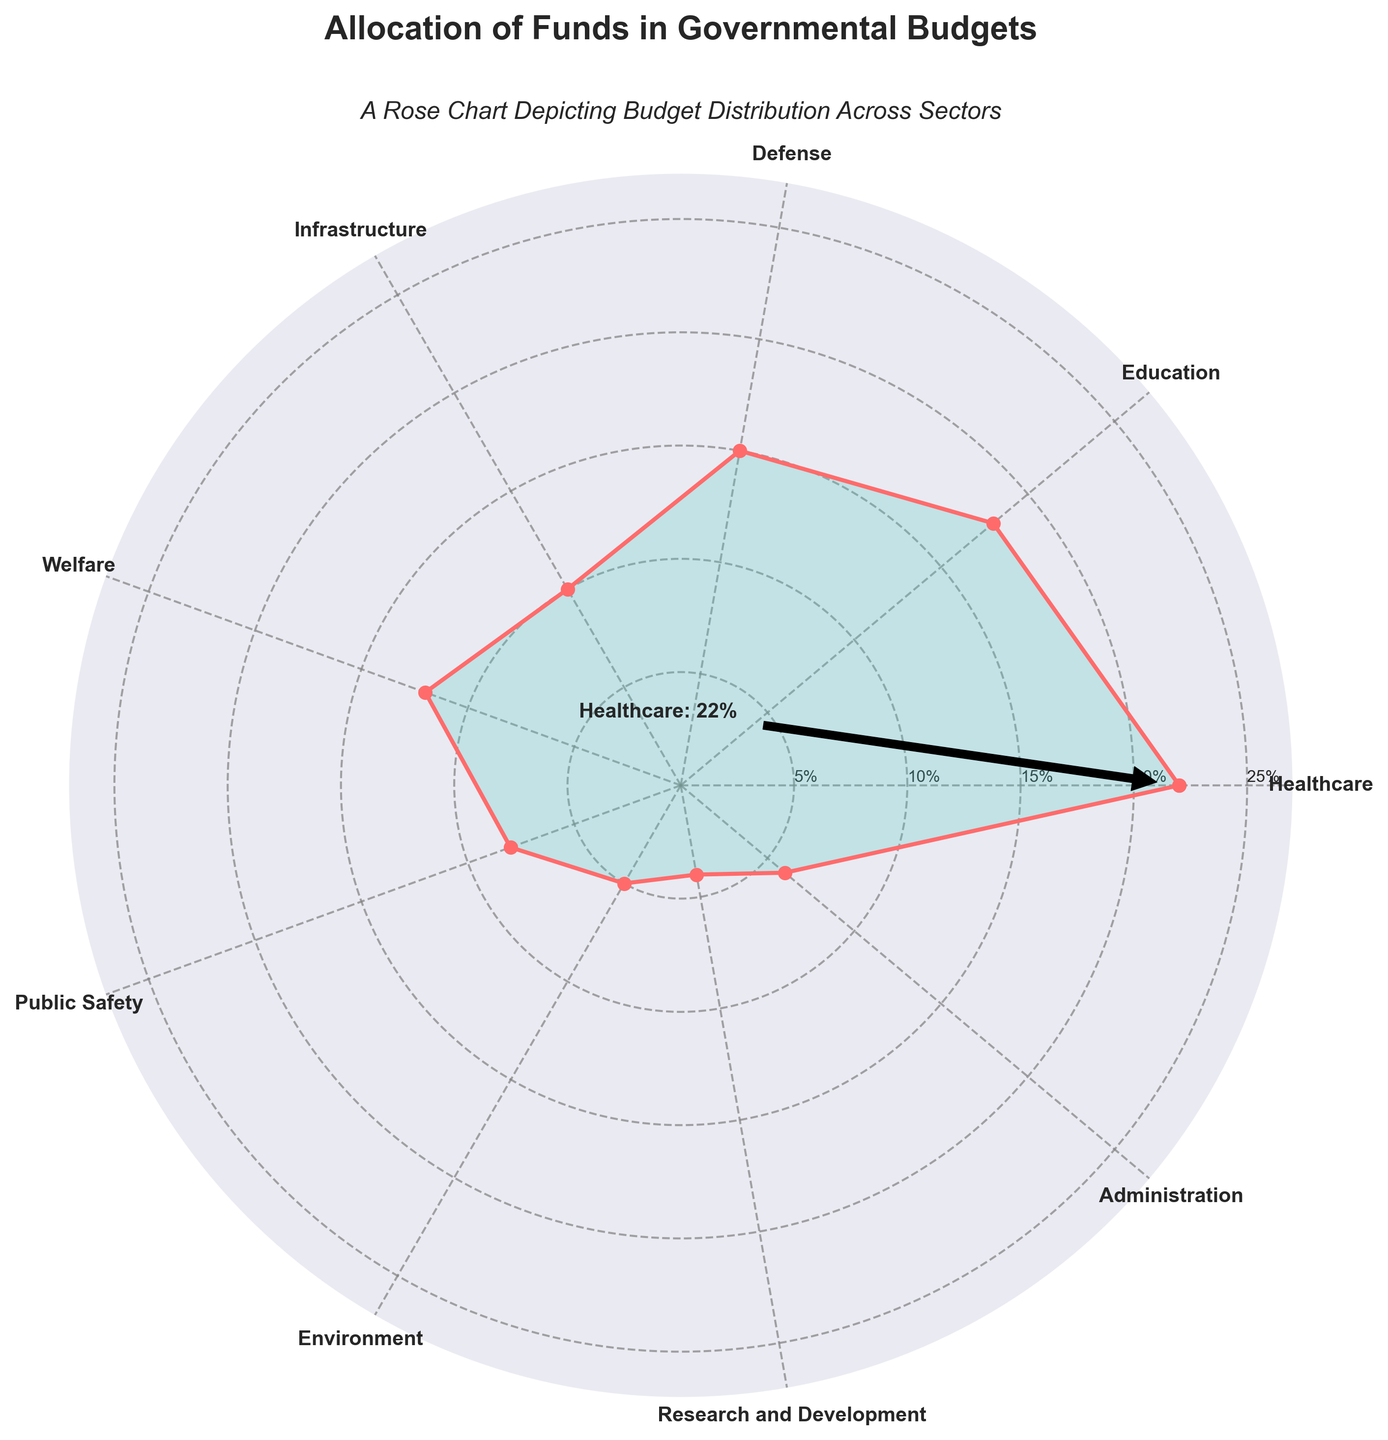What sector receives the highest allocation of funds? The highest point on the rose chart is marked with an annotation. The sector corresponding to this point is Healthcare with 22%.
Answer: Healthcare What is the title of the chart? The title is prominent at the top center of the chart, it reads "Allocation of Funds in Governmental Budgets".
Answer: Allocation of Funds in Governmental Budgets Which sector receives the least amount of funding? Look for the shortest sector on the rose chart. The sector corresponding to this is Research and Development with 4%.
Answer: Research and Development How many sectors have funding allocations greater than 10%? By examining the radial values, count the sectors with percentages above 10%. These are Healthcare (22%), Education (18%), Defense (15%), and Welfare (12%) which give us 4 sectors.
Answer: 4 Compare the funding allocated for Defense and Environment. Which sector receives more? On the rose chart, Defense is allocated 15% whereas Environment is allocated 5%. Defense has a higher allocation.
Answer: Defense What is the sum of percentages allocated to Healthcare, Education, and Defense? The percentages are 22%, 18%, and 15% respectively. Adding these gives 22 + 18 + 15 = 55%.
Answer: 55% By how much does the percentage allocation for Infrastructure exceed that for Administration? Infrastructure is allocated 10% while Administration is allocated 6%. The difference is 10 - 6 = 4%.
Answer: 4% What is the average percentage allocated across all the sectors? Sum of all percentages is 22 + 18 + 15 + 10 + 12 + 8 + 5 + 4 + 6 = 100. There are 9 sectors, so the average is 100 / 9 ≈ 11.11%.
Answer: 11.11% What color is used to fill the sectors in the rose chart? The sectors are filled with a shade of green.
Answer: Green Which sectors fall between the 5% and 10% mark? Sectors within this range are Infrastructure (10%), Public Safety (8%), Environment (5%), and Administration (6%).
Answer: Infrastructure, Public Safety, Environment, Administration 